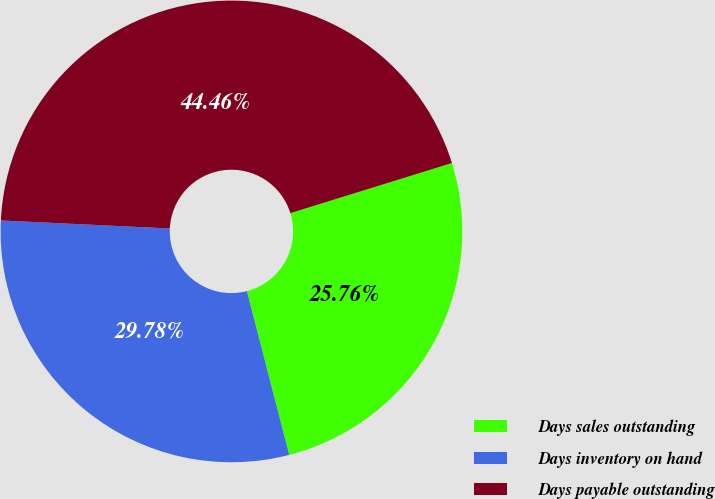Convert chart to OTSL. <chart><loc_0><loc_0><loc_500><loc_500><pie_chart><fcel>Days sales outstanding<fcel>Days inventory on hand<fcel>Days payable outstanding<nl><fcel>25.76%<fcel>29.78%<fcel>44.46%<nl></chart> 